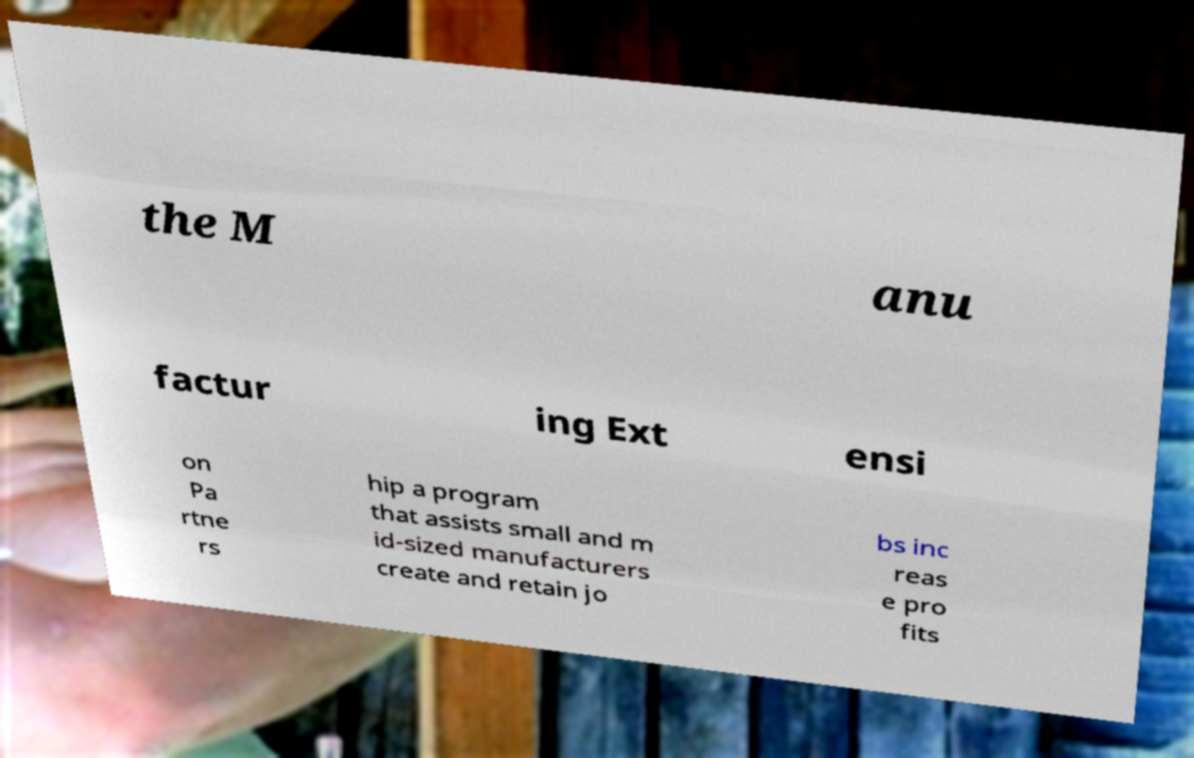There's text embedded in this image that I need extracted. Can you transcribe it verbatim? the M anu factur ing Ext ensi on Pa rtne rs hip a program that assists small and m id-sized manufacturers create and retain jo bs inc reas e pro fits 